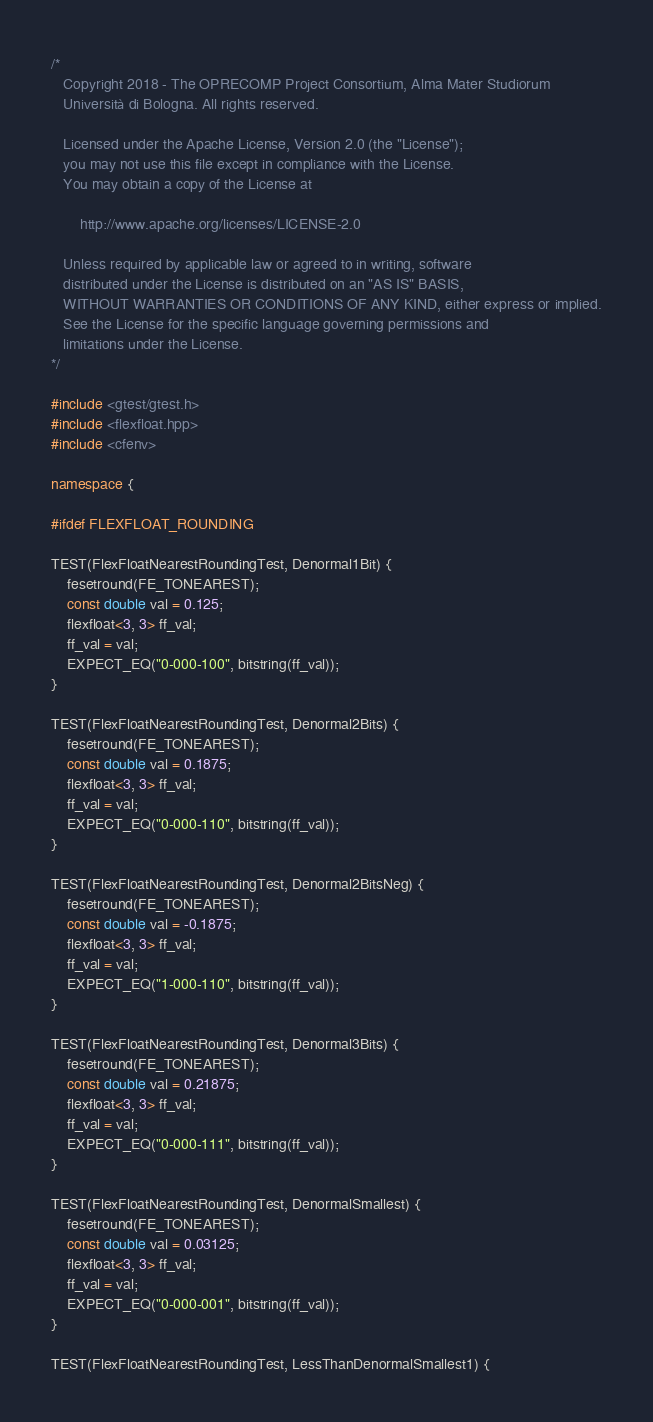<code> <loc_0><loc_0><loc_500><loc_500><_C++_>/*
   Copyright 2018 - The OPRECOMP Project Consortium, Alma Mater Studiorum
   Università di Bologna. All rights reserved.

   Licensed under the Apache License, Version 2.0 (the "License");
   you may not use this file except in compliance with the License.
   You may obtain a copy of the License at

       http://www.apache.org/licenses/LICENSE-2.0

   Unless required by applicable law or agreed to in writing, software
   distributed under the License is distributed on an "AS IS" BASIS,
   WITHOUT WARRANTIES OR CONDITIONS OF ANY KIND, either express or implied.
   See the License for the specific language governing permissions and
   limitations under the License.
*/

#include <gtest/gtest.h>
#include <flexfloat.hpp>
#include <cfenv>

namespace {

#ifdef FLEXFLOAT_ROUNDING

TEST(FlexFloatNearestRoundingTest, Denormal1Bit) {
    fesetround(FE_TONEAREST);
    const double val = 0.125;
    flexfloat<3, 3> ff_val;
    ff_val = val;
    EXPECT_EQ("0-000-100", bitstring(ff_val));
}

TEST(FlexFloatNearestRoundingTest, Denormal2Bits) {
    fesetround(FE_TONEAREST);
    const double val = 0.1875;
    flexfloat<3, 3> ff_val;
    ff_val = val;
    EXPECT_EQ("0-000-110", bitstring(ff_val));
}

TEST(FlexFloatNearestRoundingTest, Denormal2BitsNeg) {
    fesetround(FE_TONEAREST);
    const double val = -0.1875;
    flexfloat<3, 3> ff_val;
    ff_val = val;
    EXPECT_EQ("1-000-110", bitstring(ff_val));
}

TEST(FlexFloatNearestRoundingTest, Denormal3Bits) {
    fesetround(FE_TONEAREST);
    const double val = 0.21875;
    flexfloat<3, 3> ff_val;
    ff_val = val;
    EXPECT_EQ("0-000-111", bitstring(ff_val));
}

TEST(FlexFloatNearestRoundingTest, DenormalSmallest) {
    fesetround(FE_TONEAREST);
    const double val = 0.03125;
    flexfloat<3, 3> ff_val;
    ff_val = val;
    EXPECT_EQ("0-000-001", bitstring(ff_val));
}

TEST(FlexFloatNearestRoundingTest, LessThanDenormalSmallest1) {</code> 